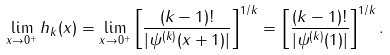Convert formula to latex. <formula><loc_0><loc_0><loc_500><loc_500>\lim _ { x \to 0 ^ { + } } h _ { k } ( x ) = \lim _ { x \to 0 ^ { + } } \left [ \frac { ( k - 1 ) ! } { | \psi ^ { ( k ) } ( x + 1 ) | } \right ] ^ { 1 / k } = \left [ \frac { ( k - 1 ) ! } { | \psi ^ { ( k ) } ( 1 ) | } \right ] ^ { 1 / k } .</formula> 